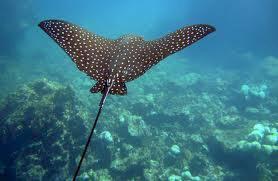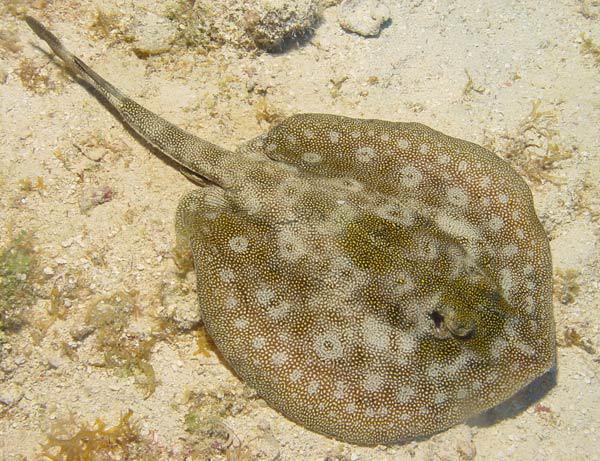The first image is the image on the left, the second image is the image on the right. Given the left and right images, does the statement "Right image shows one pale, almost white stingray." hold true? Answer yes or no. No. The first image is the image on the left, the second image is the image on the right. Examine the images to the left and right. Is the description "A single spotted ray is swimming directly away from the camera." accurate? Answer yes or no. Yes. 